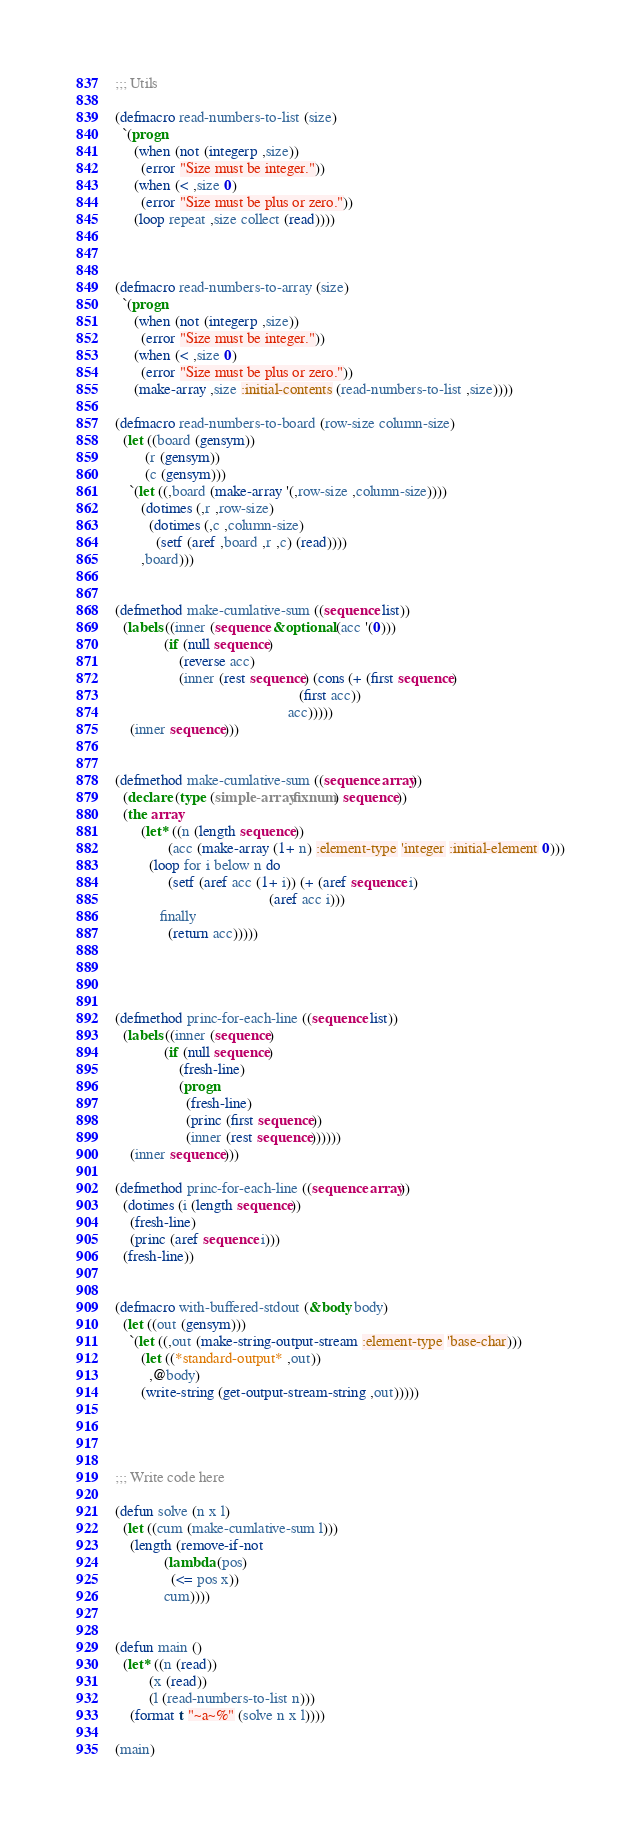<code> <loc_0><loc_0><loc_500><loc_500><_Lisp_>;;; Utils

(defmacro read-numbers-to-list (size)
  `(progn
     (when (not (integerp ,size))
       (error "Size must be integer."))
     (when (< ,size 0)
       (error "Size must be plus or zero."))
     (loop repeat ,size collect (read))))



(defmacro read-numbers-to-array (size)
  `(progn
     (when (not (integerp ,size))
       (error "Size must be integer."))
     (when (< ,size 0)
       (error "Size must be plus or zero."))
     (make-array ,size :initial-contents (read-numbers-to-list ,size))))

(defmacro read-numbers-to-board (row-size column-size)
  (let ((board (gensym))
        (r (gensym))
        (c (gensym)))
    `(let ((,board (make-array '(,row-size ,column-size))))
       (dotimes (,r ,row-size)
         (dotimes (,c ,column-size)
           (setf (aref ,board ,r ,c) (read))))
       ,board)))


(defmethod make-cumlative-sum ((sequence list))
  (labels ((inner (sequence &optional (acc '(0)))
             (if (null sequence)
                 (reverse acc)
                 (inner (rest sequence) (cons (+ (first sequence)
                                                 (first acc))
                                              acc)))))
    (inner sequence)))


(defmethod make-cumlative-sum ((sequence array))
  (declare (type (simple-array fixnum) sequence))
  (the array
       (let* ((n (length sequence))
              (acc (make-array (1+ n) :element-type 'integer :initial-element 0)))
         (loop for i below n do
              (setf (aref acc (1+ i)) (+ (aref sequence i)
                                         (aref acc i)))
            finally
              (return acc)))))




(defmethod princ-for-each-line ((sequence list))
  (labels ((inner (sequence)
             (if (null sequence)
                 (fresh-line)
                 (progn
                   (fresh-line)
                   (princ (first sequence))
                   (inner (rest sequence))))))
    (inner sequence)))

(defmethod princ-for-each-line ((sequence array))
  (dotimes (i (length sequence))
    (fresh-line)
    (princ (aref sequence i)))
  (fresh-line))


(defmacro with-buffered-stdout (&body body)
  (let ((out (gensym)))
    `(let ((,out (make-string-output-stream :element-type 'base-char)))
       (let ((*standard-output* ,out))
         ,@body)
       (write-string (get-output-stream-string ,out)))))




;;; Write code here

(defun solve (n x l)
  (let ((cum (make-cumlative-sum l)))
    (length (remove-if-not
             (lambda (pos)
               (<= pos x))
             cum))))


(defun main ()
  (let* ((n (read))
         (x (read))
         (l (read-numbers-to-list n)))
    (format t "~a~%" (solve n x l))))

(main)
</code> 